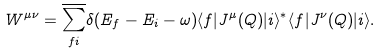Convert formula to latex. <formula><loc_0><loc_0><loc_500><loc_500>W ^ { \mu \nu } = \overline { \sum _ { f i } } \delta ( E _ { f } - E _ { i } - \omega ) \langle f | J ^ { \mu } ( Q ) | i \rangle ^ { * } \langle f | J ^ { \nu } ( Q ) | i \rangle .</formula> 